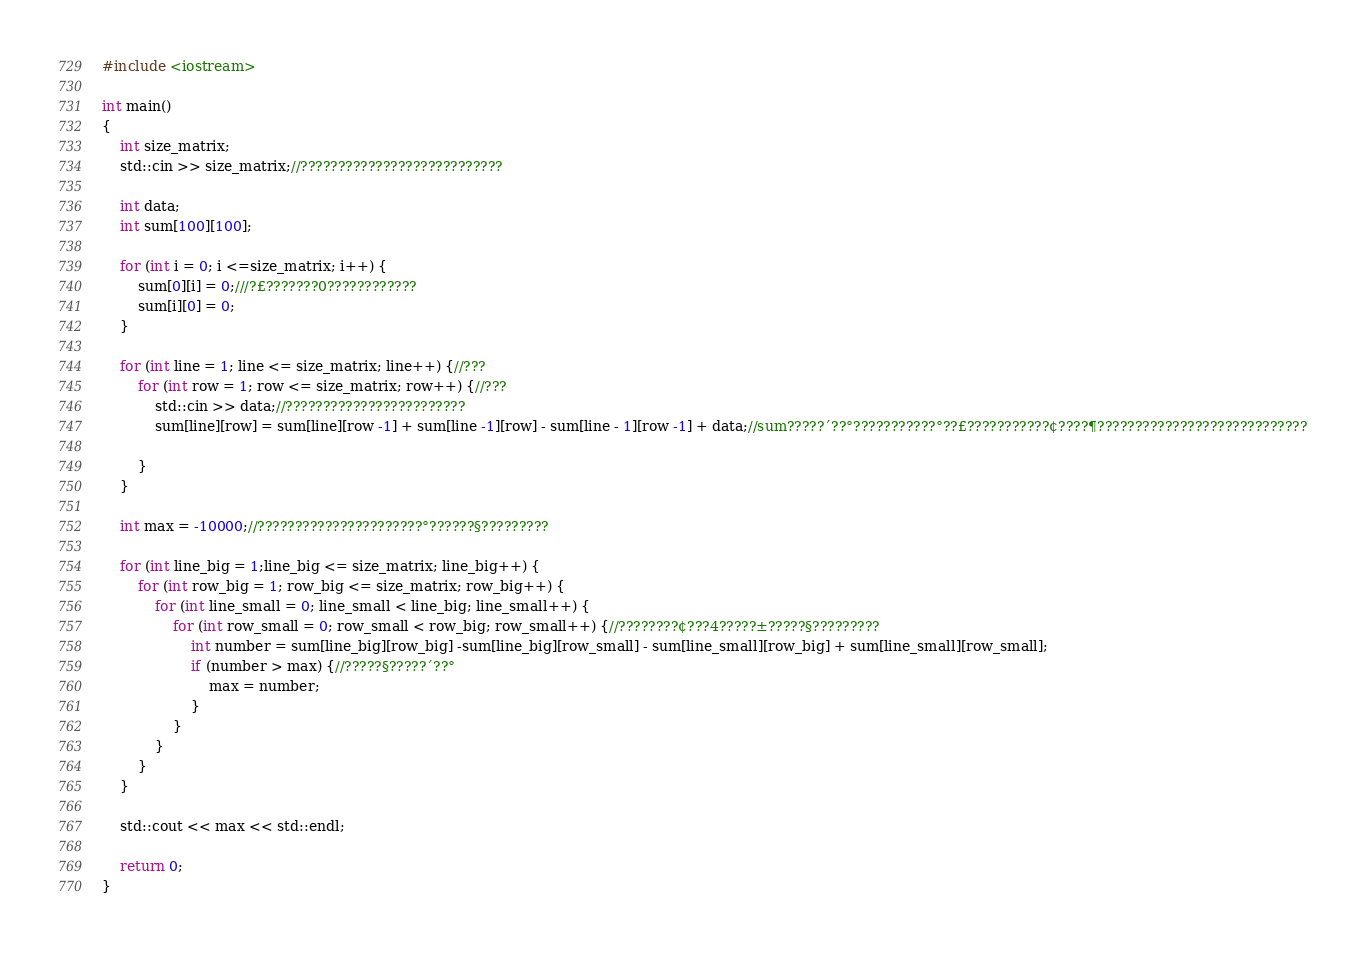<code> <loc_0><loc_0><loc_500><loc_500><_C++_>#include <iostream>

int main()
{
    int size_matrix;
    std::cin >> size_matrix;//???????????????????????????

    int data;
    int sum[100][100];
    
    for (int i = 0; i <=size_matrix; i++) {
        sum[0][i] = 0;///?£???????0????????????
        sum[i][0] = 0;
    }

    for (int line = 1; line <= size_matrix; line++) {//???
        for (int row = 1; row <= size_matrix; row++) {//???
            std::cin >> data;//????????????????????????
            sum[line][row] = sum[line][row -1] + sum[line -1][row] - sum[line - 1][row -1] + data;//sum?????´??°???????????°??£???????????¢????¶????????????????????????????

        }
    }

    int max = -10000;//??????????????????????°??????§?????????

    for (int line_big = 1;line_big <= size_matrix; line_big++) {
        for (int row_big = 1; row_big <= size_matrix; row_big++) {
            for (int line_small = 0; line_small < line_big; line_small++) {
                for (int row_small = 0; row_small < row_big; row_small++) {//????????¢???4?????±?????§?????????
                    int number = sum[line_big][row_big] -sum[line_big][row_small] - sum[line_small][row_big] + sum[line_small][row_small];
                    if (number > max) {//?????§?????´??°
                        max = number;
                    }
                }
            }
        }
    }

    std::cout << max << std::endl;

    return 0;
}</code> 